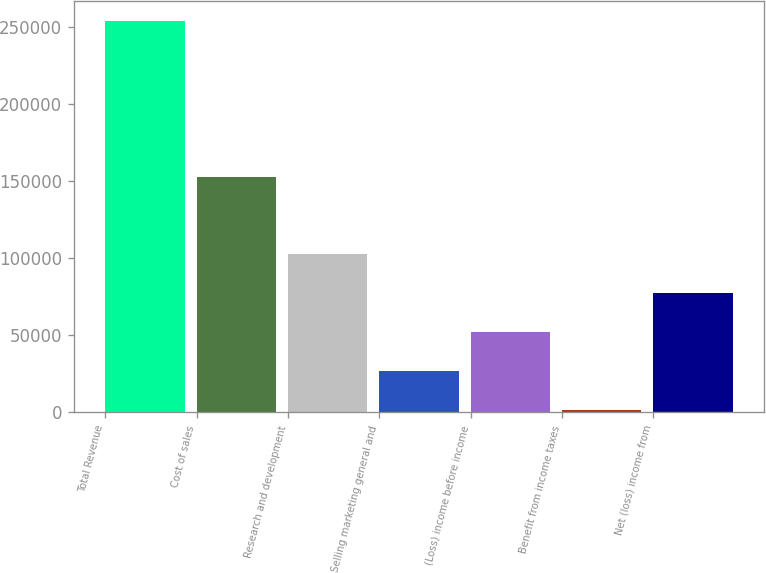<chart> <loc_0><loc_0><loc_500><loc_500><bar_chart><fcel>Total Revenue<fcel>Cost of sales<fcel>Research and development<fcel>Selling marketing general and<fcel>(Loss) income before income<fcel>Benefit from income taxes<fcel>Net (loss) income from<nl><fcel>254008<fcel>152483<fcel>102453<fcel>26676.1<fcel>51935.2<fcel>1417<fcel>77194.3<nl></chart> 